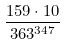<formula> <loc_0><loc_0><loc_500><loc_500>\frac { 1 5 9 \cdot 1 0 } { 3 6 3 ^ { 3 4 7 } }</formula> 